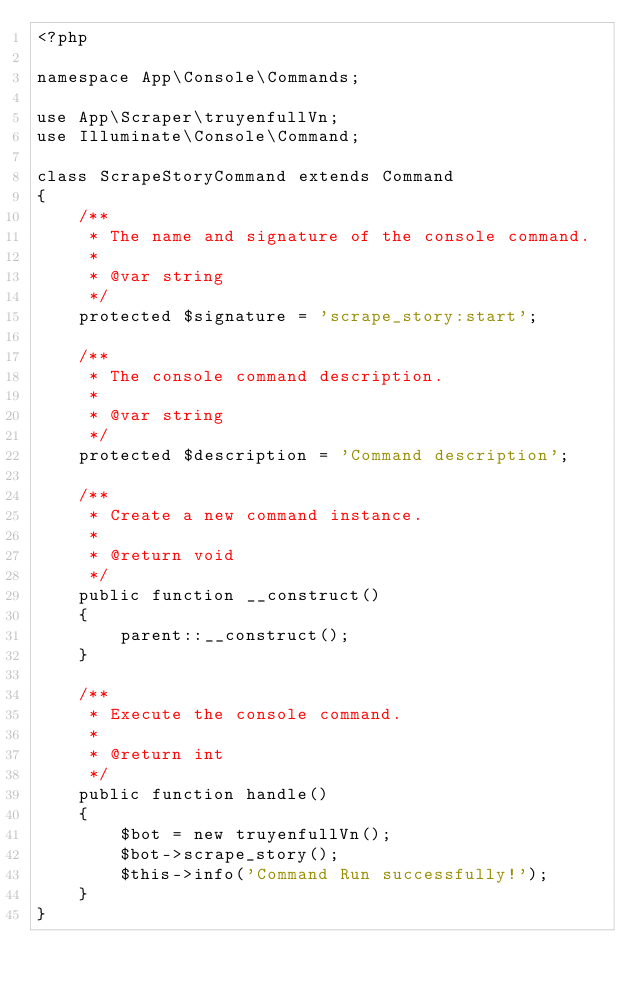<code> <loc_0><loc_0><loc_500><loc_500><_PHP_><?php

namespace App\Console\Commands;

use App\Scraper\truyenfullVn;
use Illuminate\Console\Command;

class ScrapeStoryCommand extends Command
{
    /**
     * The name and signature of the console command.
     *
     * @var string
     */
    protected $signature = 'scrape_story:start';

    /**
     * The console command description.
     *
     * @var string
     */
    protected $description = 'Command description';

    /**
     * Create a new command instance.
     *
     * @return void
     */
    public function __construct()
    {
        parent::__construct();
    }

    /**
     * Execute the console command.
     *
     * @return int
     */
    public function handle()
    {
        $bot = new truyenfullVn();
        $bot->scrape_story();
        $this->info('Command Run successfully!');
    }
}
</code> 